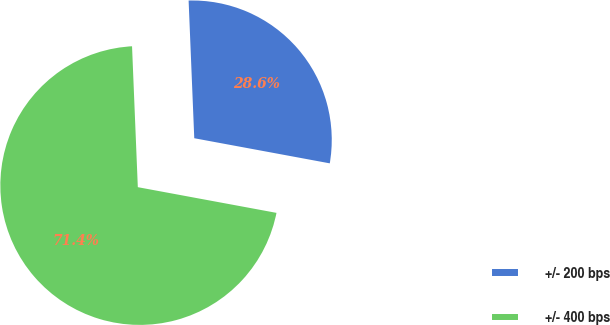Convert chart to OTSL. <chart><loc_0><loc_0><loc_500><loc_500><pie_chart><fcel>+/- 200 bps<fcel>+/- 400 bps<nl><fcel>28.57%<fcel>71.43%<nl></chart> 